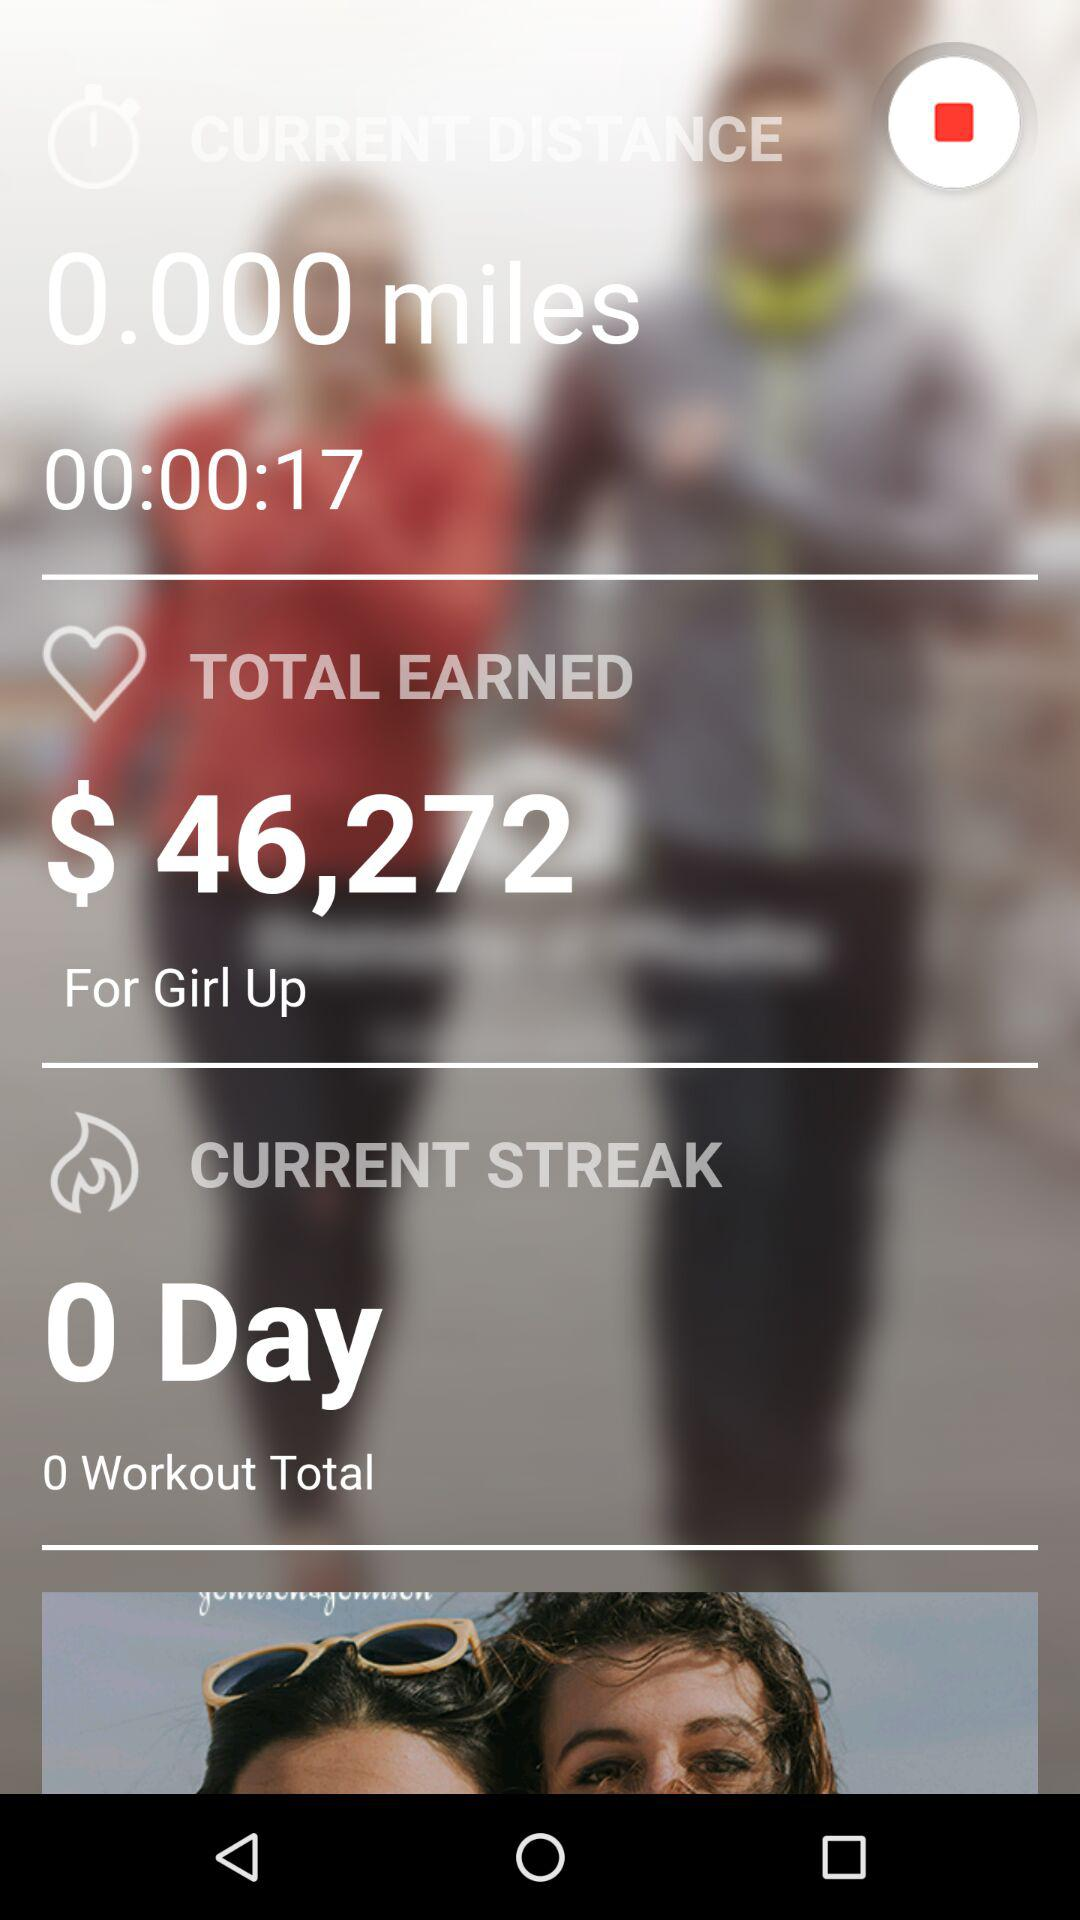What is the "Workout Total"? The "Workout Total" is 0. 